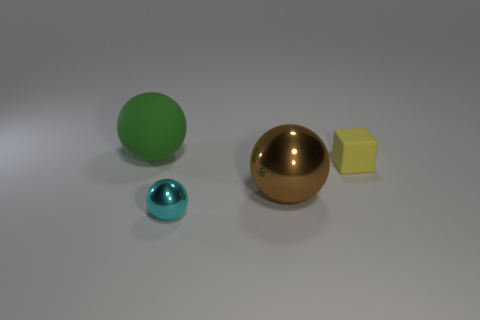How many metallic things are either brown balls or tiny cyan spheres?
Offer a terse response. 2. How many brown spheres are in front of the rubber object in front of the green matte ball?
Provide a short and direct response. 1. What shape is the thing that is in front of the green rubber sphere and behind the large brown object?
Ensure brevity in your answer.  Cube. What material is the thing that is behind the yellow object that is in front of the matte thing behind the small rubber block made of?
Your answer should be very brief. Rubber. What is the material of the green object?
Your answer should be very brief. Rubber. Is the material of the brown ball the same as the thing that is in front of the brown ball?
Keep it short and to the point. Yes. There is a sphere that is behind the large object that is right of the large green matte object; what is its color?
Give a very brief answer. Green. How big is the sphere that is behind the cyan shiny object and on the right side of the rubber sphere?
Make the answer very short. Large. What number of other things are the same shape as the small rubber thing?
Make the answer very short. 0. There is a big brown metal object; does it have the same shape as the object that is on the left side of the cyan sphere?
Offer a terse response. Yes. 